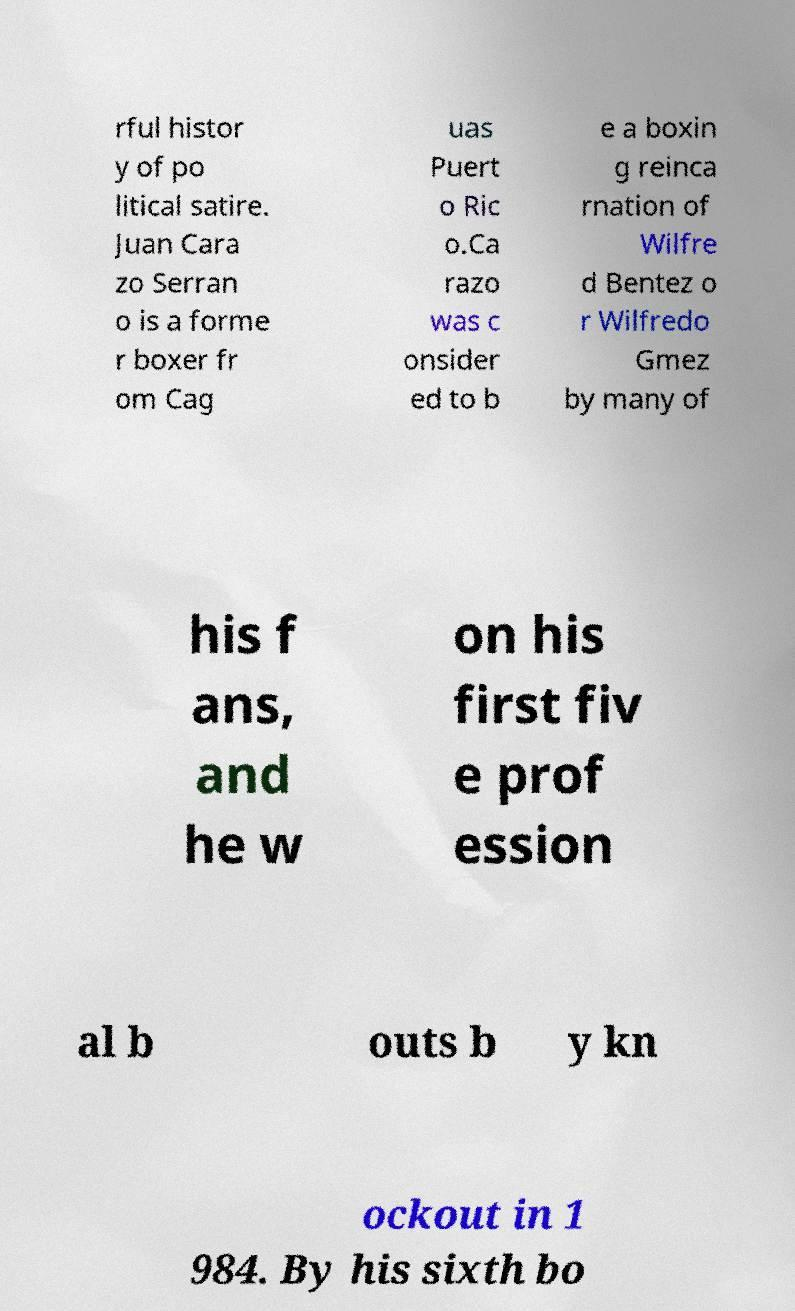Can you read and provide the text displayed in the image?This photo seems to have some interesting text. Can you extract and type it out for me? rful histor y of po litical satire. Juan Cara zo Serran o is a forme r boxer fr om Cag uas Puert o Ric o.Ca razo was c onsider ed to b e a boxin g reinca rnation of Wilfre d Bentez o r Wilfredo Gmez by many of his f ans, and he w on his first fiv e prof ession al b outs b y kn ockout in 1 984. By his sixth bo 